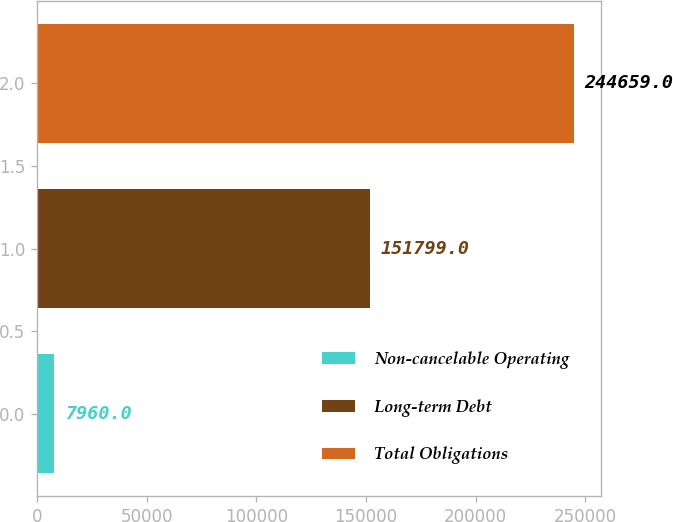<chart> <loc_0><loc_0><loc_500><loc_500><bar_chart><fcel>Non-cancelable Operating<fcel>Long-term Debt<fcel>Total Obligations<nl><fcel>7960<fcel>151799<fcel>244659<nl></chart> 